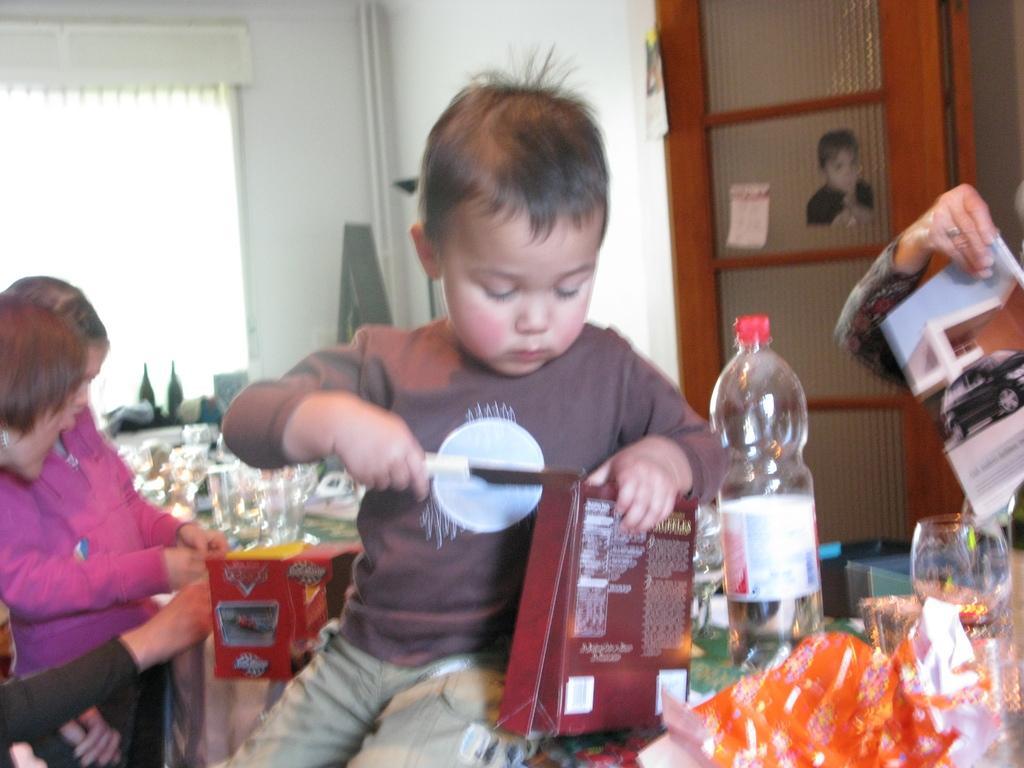How would you summarize this image in a sentence or two? The image is inside the room. In the image there is a boy sitting on table and he is also holding knife on one hand and box on another hand. On table we can see water bottle,glass,papers, on right side we can also see a person holding something on her hand. On left side there are two people in background we can see a door,window and a wall which is in white color. 